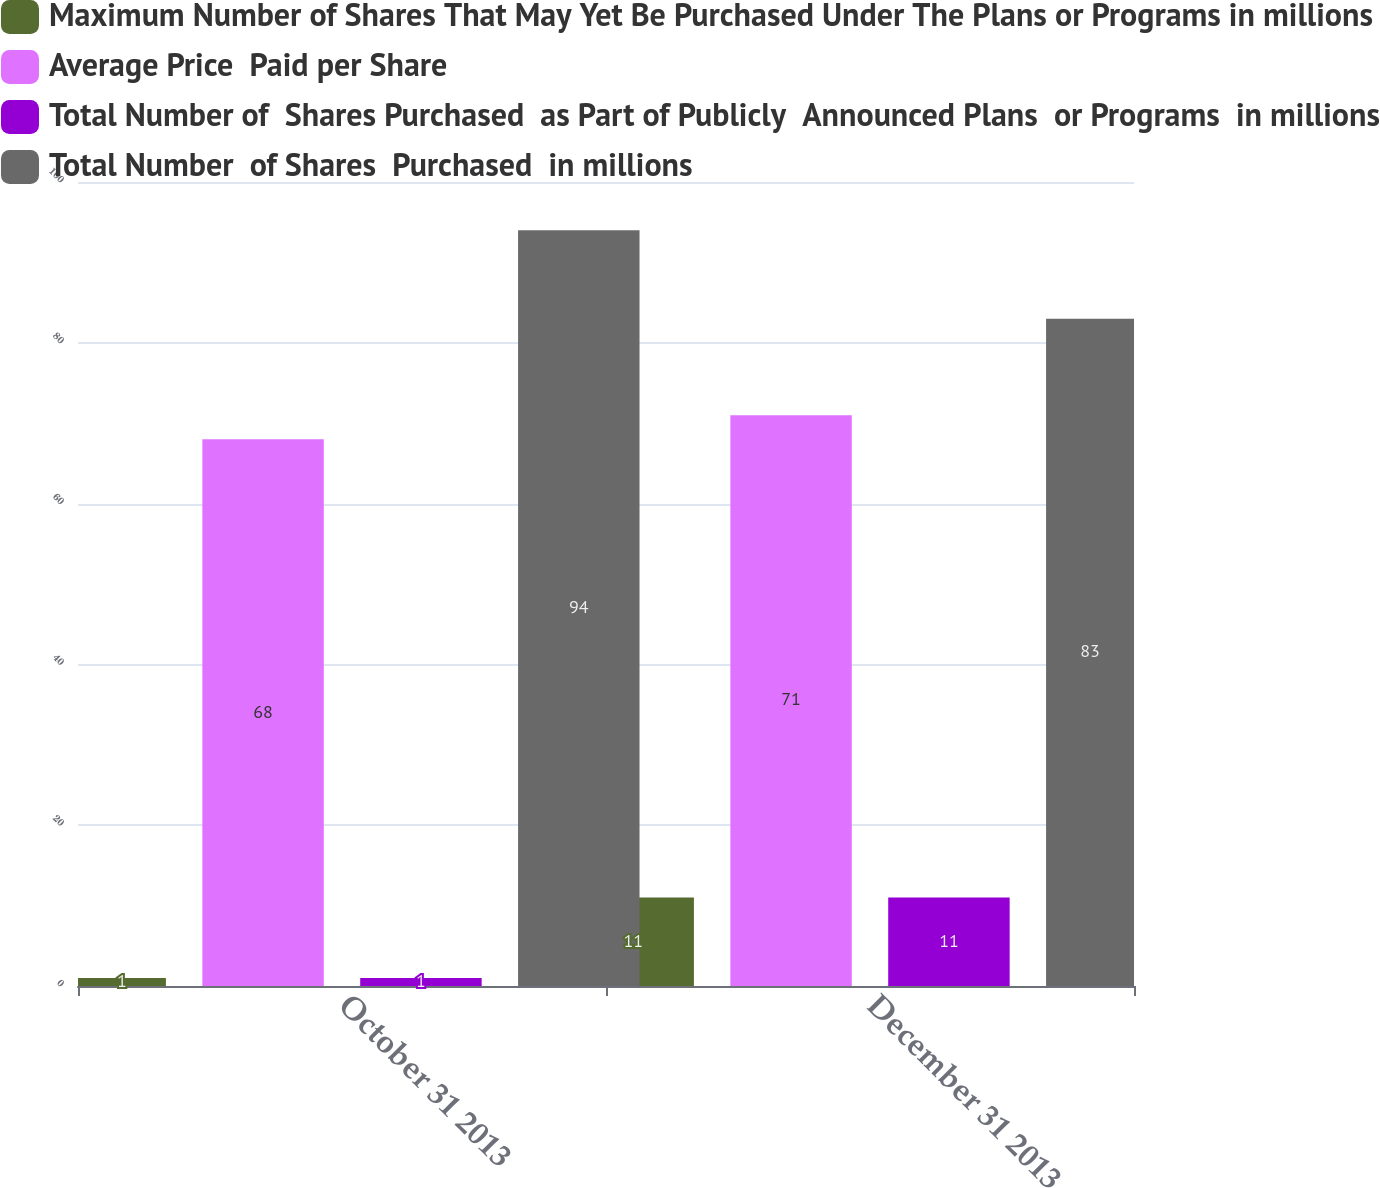Convert chart to OTSL. <chart><loc_0><loc_0><loc_500><loc_500><stacked_bar_chart><ecel><fcel>October 31 2013<fcel>December 31 2013<nl><fcel>Maximum Number of Shares That May Yet Be Purchased Under The Plans or Programs in millions<fcel>1<fcel>11<nl><fcel>Average Price  Paid per Share<fcel>68<fcel>71<nl><fcel>Total Number of  Shares Purchased  as Part of Publicly  Announced Plans  or Programs  in millions<fcel>1<fcel>11<nl><fcel>Total Number  of Shares  Purchased  in millions<fcel>94<fcel>83<nl></chart> 